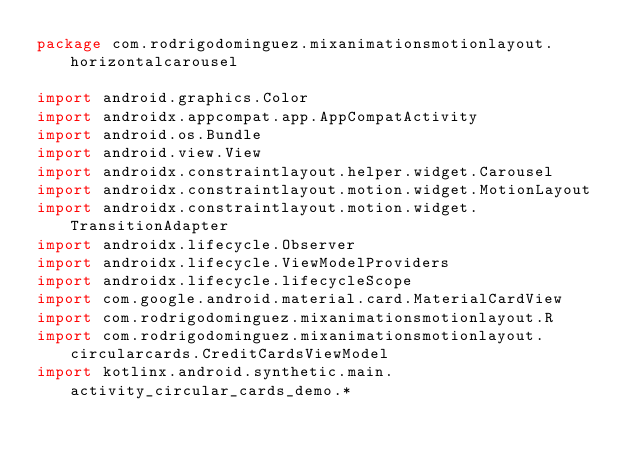Convert code to text. <code><loc_0><loc_0><loc_500><loc_500><_Kotlin_>package com.rodrigodominguez.mixanimationsmotionlayout.horizontalcarousel

import android.graphics.Color
import androidx.appcompat.app.AppCompatActivity
import android.os.Bundle
import android.view.View
import androidx.constraintlayout.helper.widget.Carousel
import androidx.constraintlayout.motion.widget.MotionLayout
import androidx.constraintlayout.motion.widget.TransitionAdapter
import androidx.lifecycle.Observer
import androidx.lifecycle.ViewModelProviders
import androidx.lifecycle.lifecycleScope
import com.google.android.material.card.MaterialCardView
import com.rodrigodominguez.mixanimationsmotionlayout.R
import com.rodrigodominguez.mixanimationsmotionlayout.circularcards.CreditCardsViewModel
import kotlinx.android.synthetic.main.activity_circular_cards_demo.*</code> 